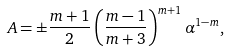<formula> <loc_0><loc_0><loc_500><loc_500>A = \pm \frac { m + 1 } { 2 } \left ( \frac { m - 1 } { m + 3 } \right ) ^ { m + 1 } \alpha ^ { 1 - m } ,</formula> 